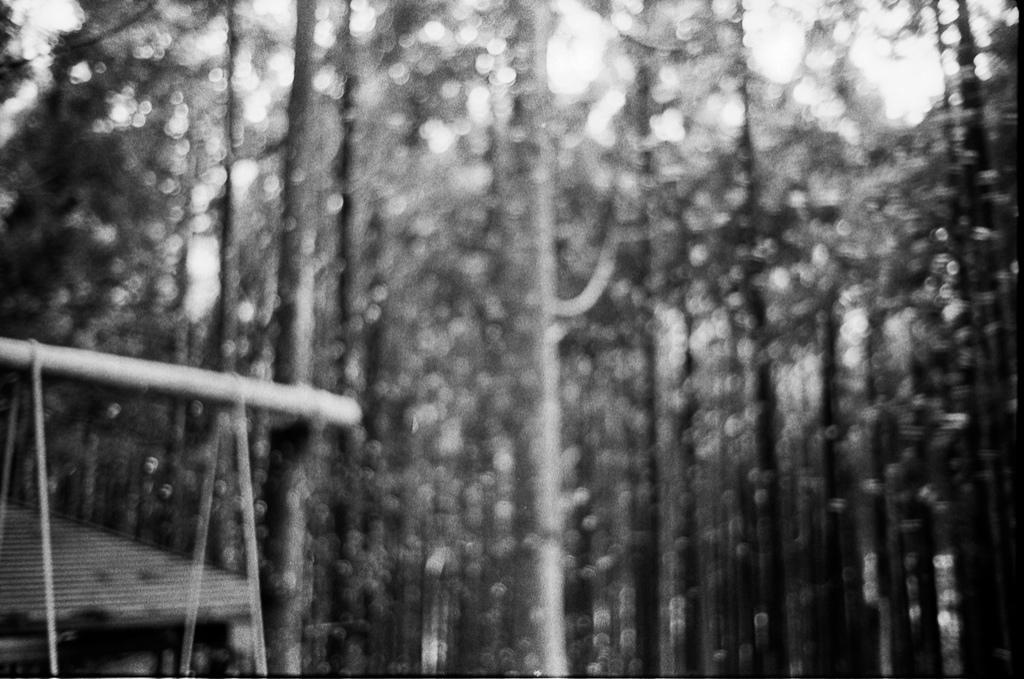In one or two sentences, can you explain what this image depicts? In this picture I can see trees and a wooden pole on the left side and looks like a house at the bottom left corner of the picture. 